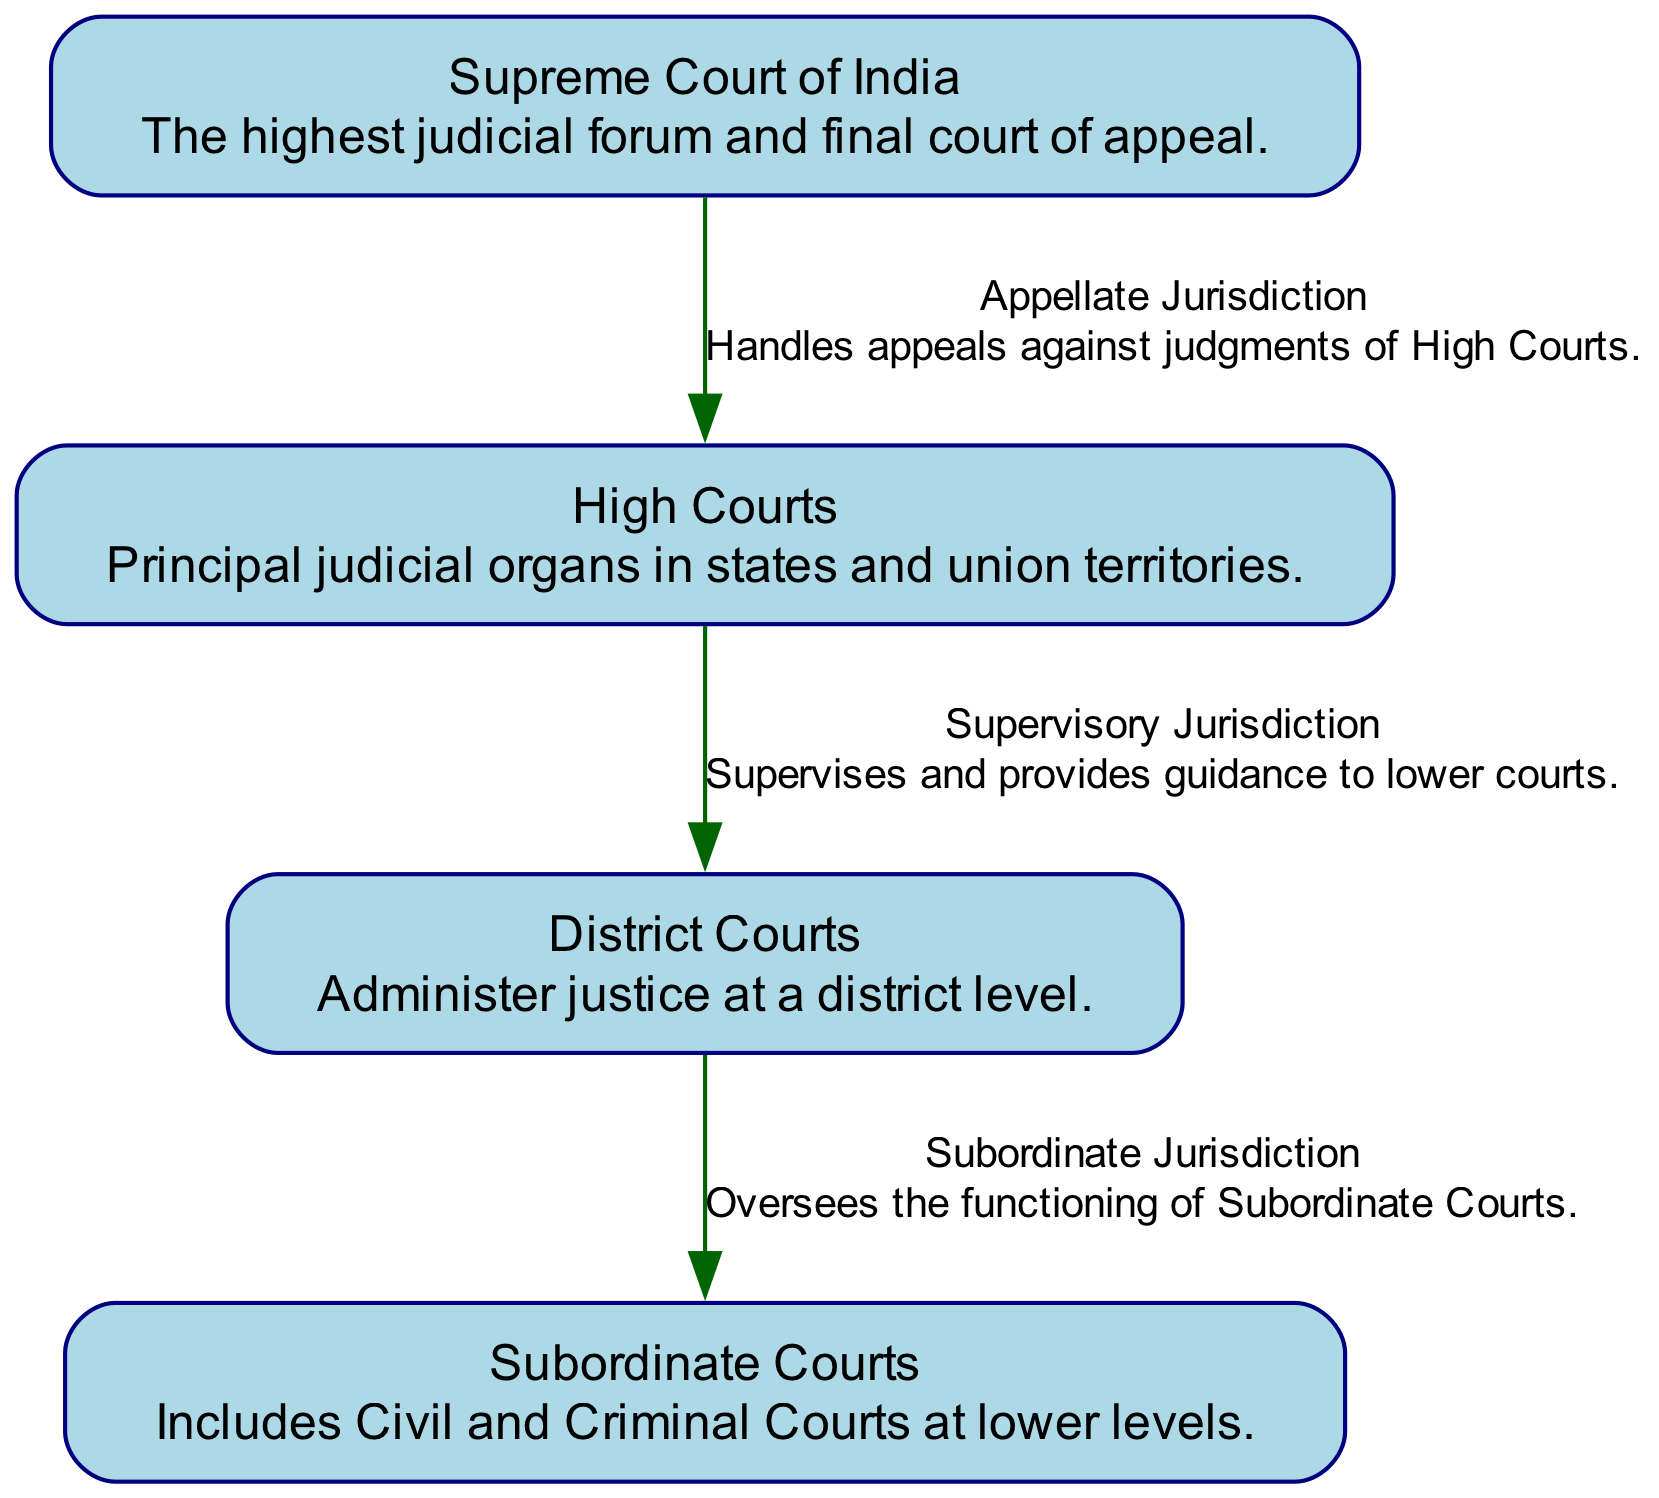What is the highest level of the judiciary represented in the diagram? The diagram clearly illustrates the structure of the Indian Judiciary System, with the "Supreme Court of India" positioned at the top, indicating that it is the highest court.
Answer: Supreme Court of India How many nodes are present in the diagram? The diagram includes four distinct nodes: the Supreme Court, High Courts, District Courts, and Subordinate Courts. By counting these, we determine that there are a total of four nodes.
Answer: 4 What type of jurisdiction does the Supreme Court exercise over the High Courts? The diagram indicates that the Supreme Court has "Appellate Jurisdiction" over the High Courts, which means it handles appeals from them. This relationship is explicitly stated on the connecting edge.
Answer: Appellate Jurisdiction Which court supervises District Courts? According to the diagram, "High Courts" oversee the District Courts as indicated by the "Supervisory Jurisdiction" label on the connection between them. This means that High Courts have the authority to guide District Courts.
Answer: High Courts What is the relationship labeled on the edge from District Courts to Subordinate Courts? The diagram shows that the relationship from District Courts to Subordinate Courts is labeled "Subordinate Jurisdiction." This means that District Courts have oversight over the functioning of Subordinate Courts.
Answer: Subordinate Jurisdiction Which court in the diagram administers justice at the district level? The "District Courts" node explicitly describes its function as administering justice at a district level, making it clear that this is the role of District Courts.
Answer: District Courts What color is used to represent the nodes in the diagram? All nodes in the diagram are represented using the color "light blue," which is specified in the node attributes for consistent visual identification.
Answer: Light blue What type of courts are included under Subordinate Courts? The diagram includes Civil and Criminal Courts as part of the Subordinate Courts category, indicating that these are the lower-level courts addressed by this node.
Answer: Civil and Criminal Courts 